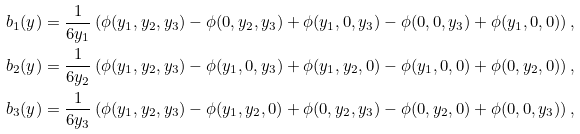<formula> <loc_0><loc_0><loc_500><loc_500>b _ { 1 } ( y ) & = \frac { 1 } { 6 y _ { 1 } } \left ( \phi ( y _ { 1 } , y _ { 2 } , y _ { 3 } ) - \phi ( 0 , y _ { 2 } , y _ { 3 } ) + \phi ( y _ { 1 } , 0 , y _ { 3 } ) - \phi ( 0 , 0 , y _ { 3 } ) + \phi ( y _ { 1 } , 0 , 0 ) \right ) , \\ b _ { 2 } ( y ) & = \frac { 1 } { 6 y _ { 2 } } \left ( \phi ( y _ { 1 } , y _ { 2 } , y _ { 3 } ) - \phi ( y _ { 1 } , 0 , y _ { 3 } ) + \phi ( y _ { 1 } , y _ { 2 } , 0 ) - \phi ( y _ { 1 } , 0 , 0 ) + \phi ( 0 , y _ { 2 } , 0 ) \right ) , \\ b _ { 3 } ( y ) & = \frac { 1 } { 6 y _ { 3 } } \left ( \phi ( y _ { 1 } , y _ { 2 } , y _ { 3 } ) - \phi ( y _ { 1 } , y _ { 2 } , 0 ) + \phi ( 0 , y _ { 2 } , y _ { 3 } ) - \phi ( 0 , y _ { 2 } , 0 ) + \phi ( 0 , 0 , y _ { 3 } ) \right ) ,</formula> 